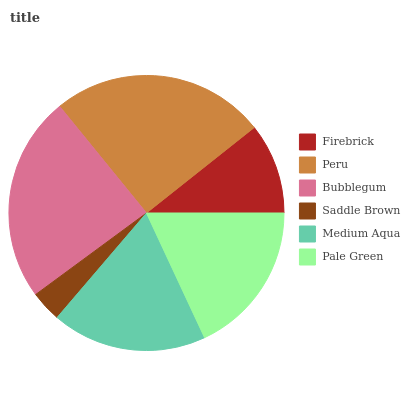Is Saddle Brown the minimum?
Answer yes or no. Yes. Is Peru the maximum?
Answer yes or no. Yes. Is Bubblegum the minimum?
Answer yes or no. No. Is Bubblegum the maximum?
Answer yes or no. No. Is Peru greater than Bubblegum?
Answer yes or no. Yes. Is Bubblegum less than Peru?
Answer yes or no. Yes. Is Bubblegum greater than Peru?
Answer yes or no. No. Is Peru less than Bubblegum?
Answer yes or no. No. Is Medium Aqua the high median?
Answer yes or no. Yes. Is Pale Green the low median?
Answer yes or no. Yes. Is Peru the high median?
Answer yes or no. No. Is Medium Aqua the low median?
Answer yes or no. No. 